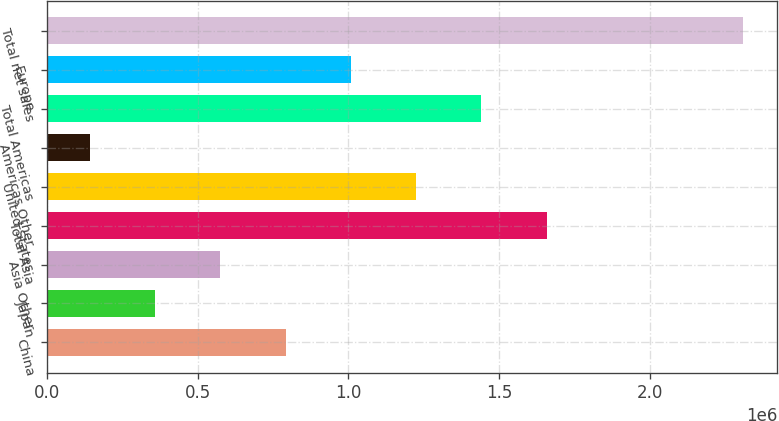Convert chart. <chart><loc_0><loc_0><loc_500><loc_500><bar_chart><fcel>China<fcel>Japan<fcel>Asia Other<fcel>Total Asia<fcel>United States<fcel>Americas Other<fcel>Total Americas<fcel>Europe<fcel>Total net sales<nl><fcel>791224<fcel>357551<fcel>574388<fcel>1.65857e+06<fcel>1.2249e+06<fcel>140715<fcel>1.44173e+06<fcel>1.00806e+06<fcel>2.30908e+06<nl></chart> 